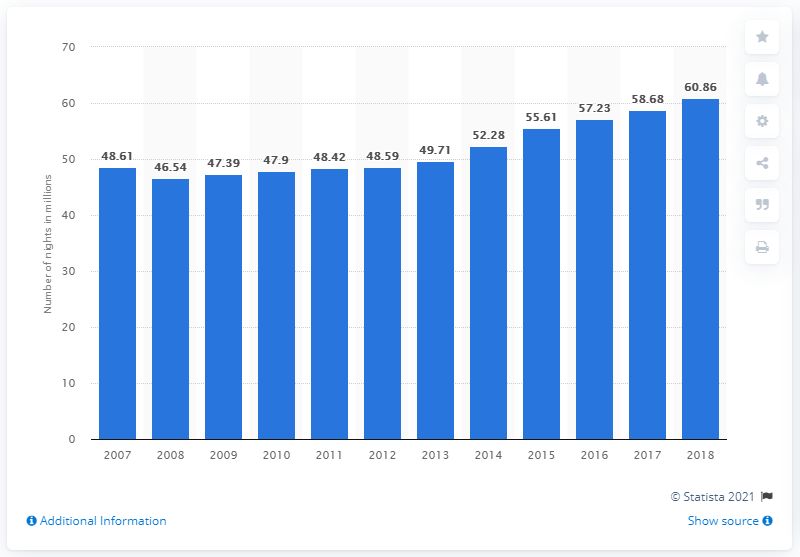Give some essential details in this illustration. During the period between 2007 and 2018, a total of 60,860 nights were spent at tourist accommodation establishments in Sweden. 